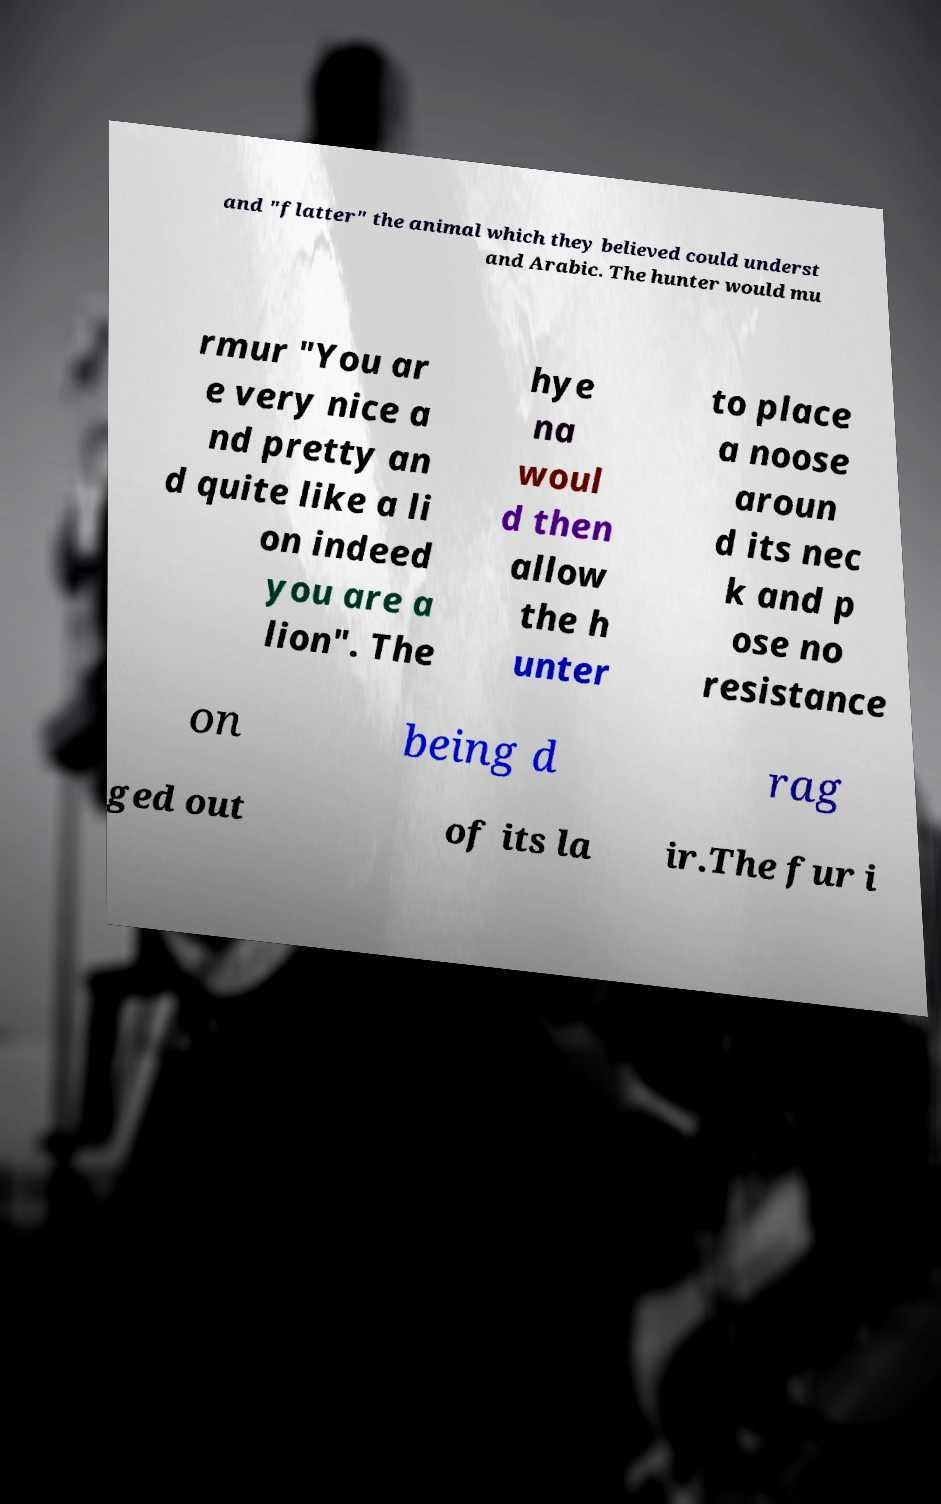Can you read and provide the text displayed in the image?This photo seems to have some interesting text. Can you extract and type it out for me? and "flatter" the animal which they believed could underst and Arabic. The hunter would mu rmur "You ar e very nice a nd pretty an d quite like a li on indeed you are a lion". The hye na woul d then allow the h unter to place a noose aroun d its nec k and p ose no resistance on being d rag ged out of its la ir.The fur i 